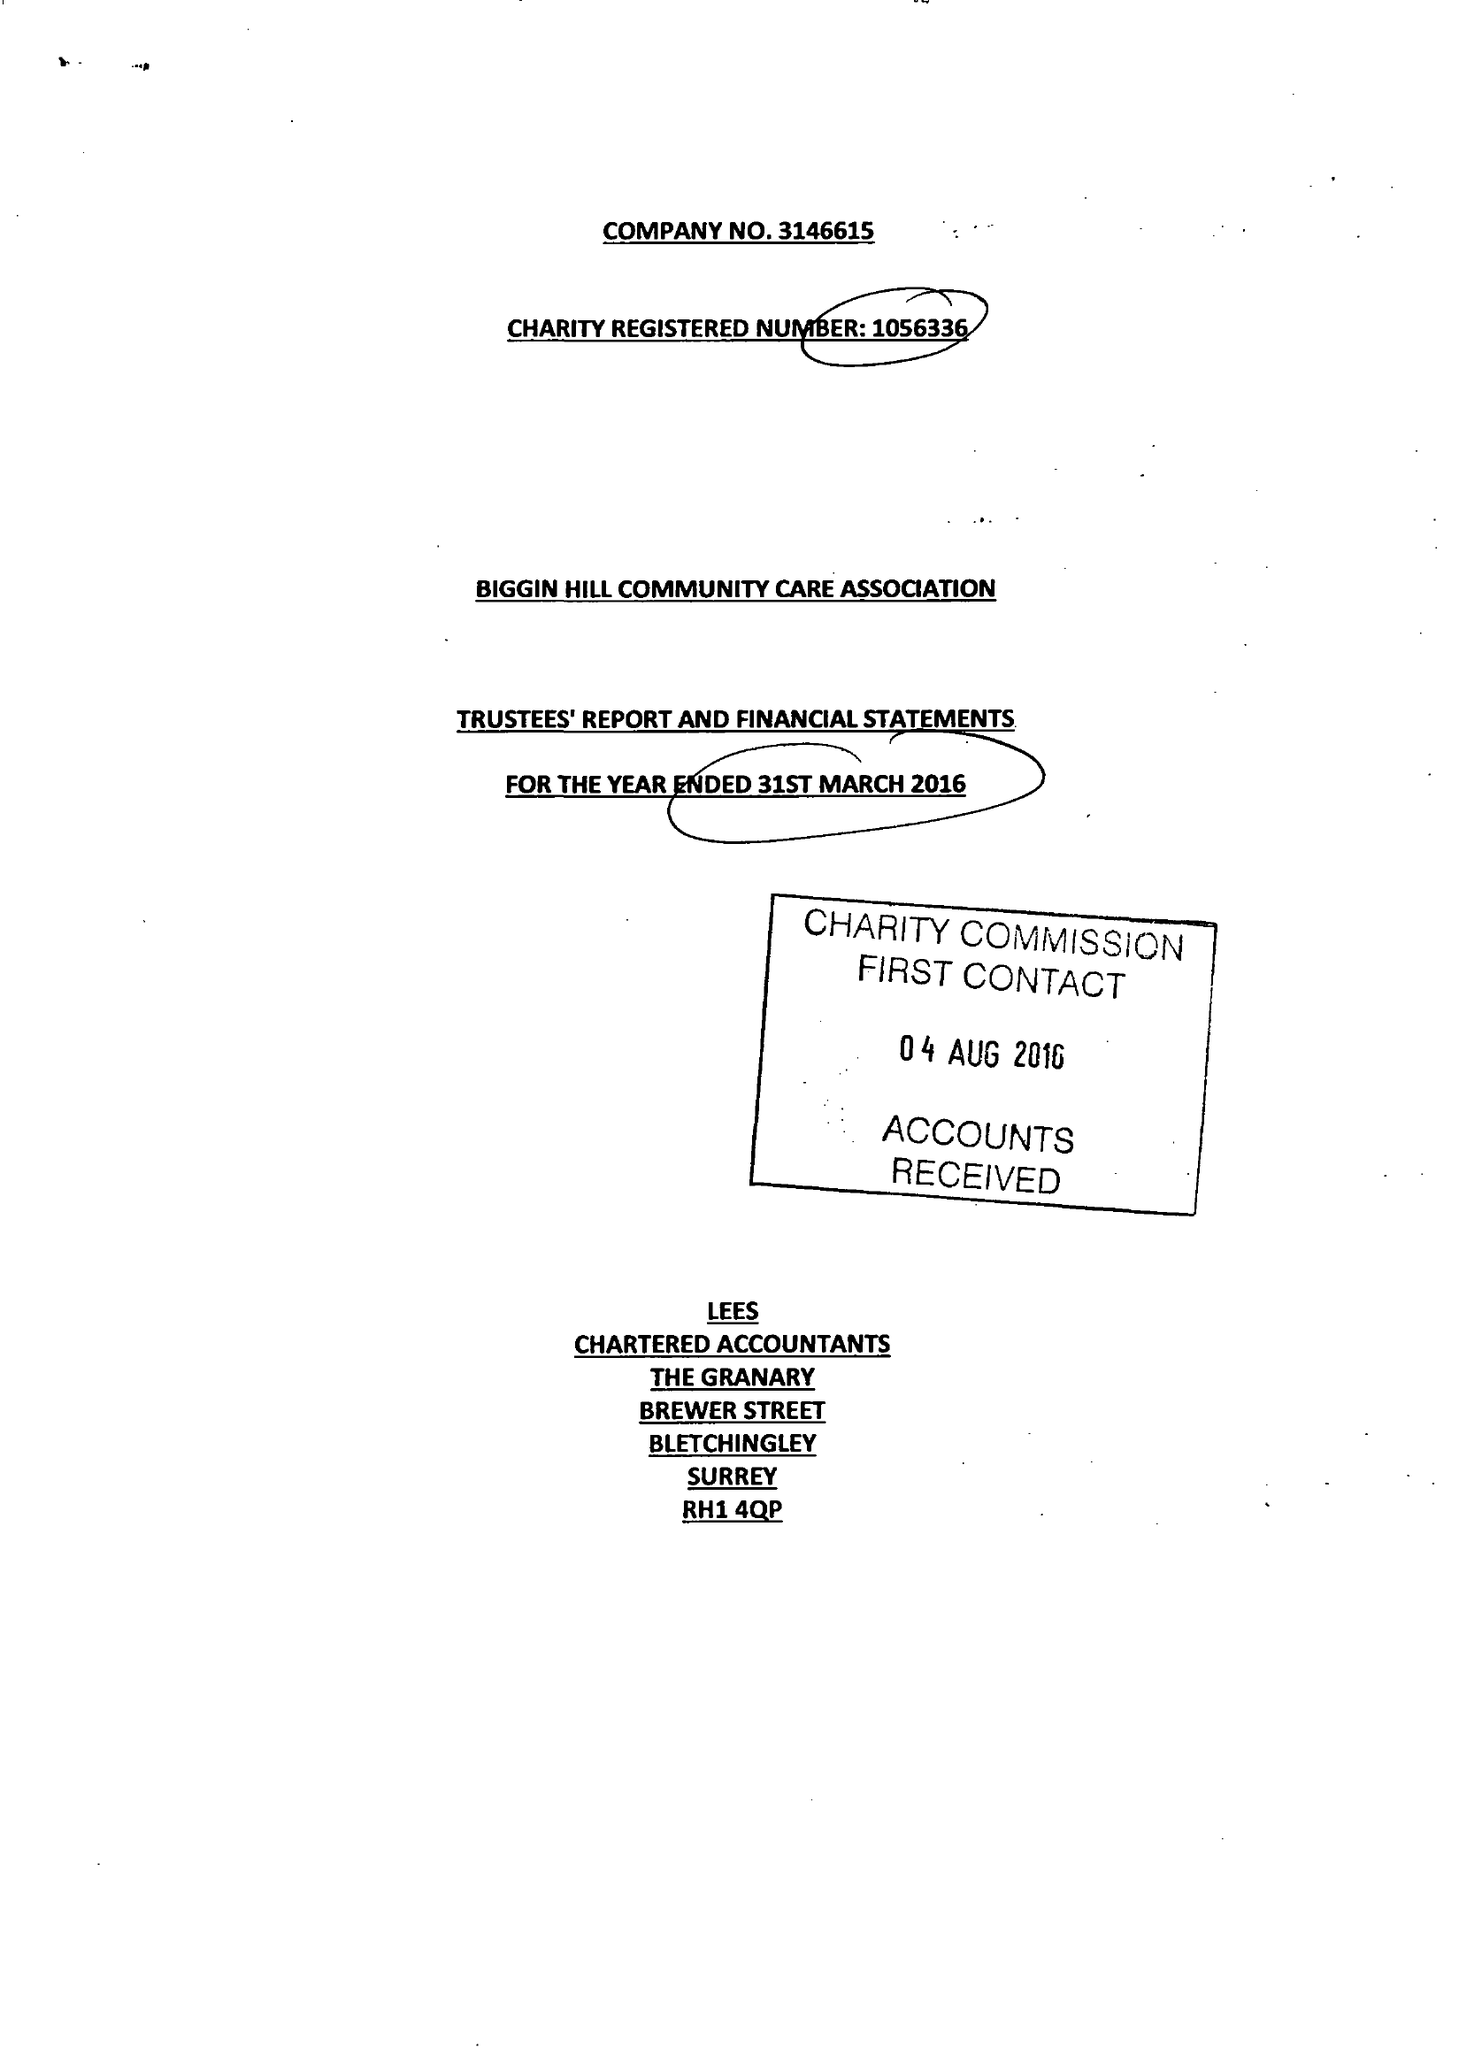What is the value for the income_annually_in_british_pounds?
Answer the question using a single word or phrase. 66534.00 